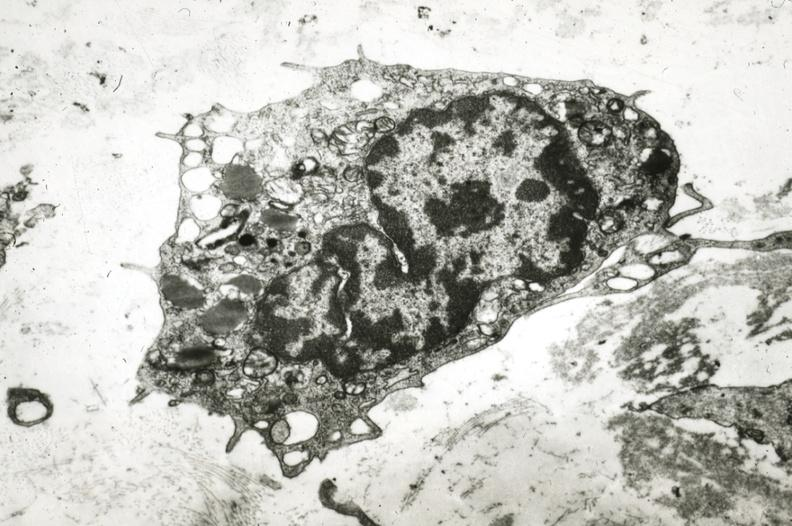does this image show monocyte in intima?
Answer the question using a single word or phrase. Yes 